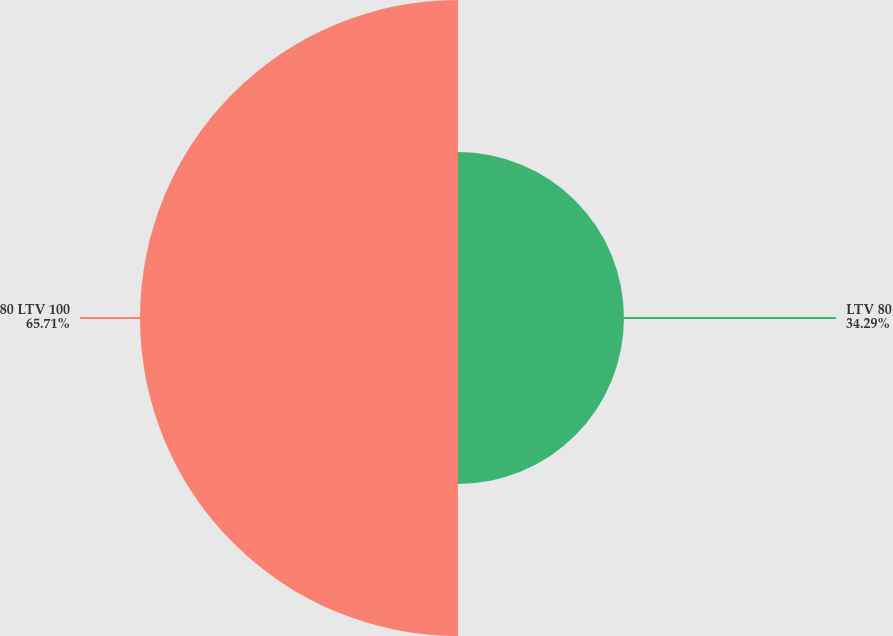Convert chart. <chart><loc_0><loc_0><loc_500><loc_500><pie_chart><fcel>LTV 80<fcel>80 LTV 100<nl><fcel>34.29%<fcel>65.71%<nl></chart> 